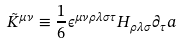<formula> <loc_0><loc_0><loc_500><loc_500>\tilde { K } ^ { \mu \nu } \equiv \frac { 1 } { 6 } \epsilon ^ { \mu \nu \rho \lambda \sigma \tau } H _ { \rho \lambda \sigma } \partial _ { \tau } a</formula> 